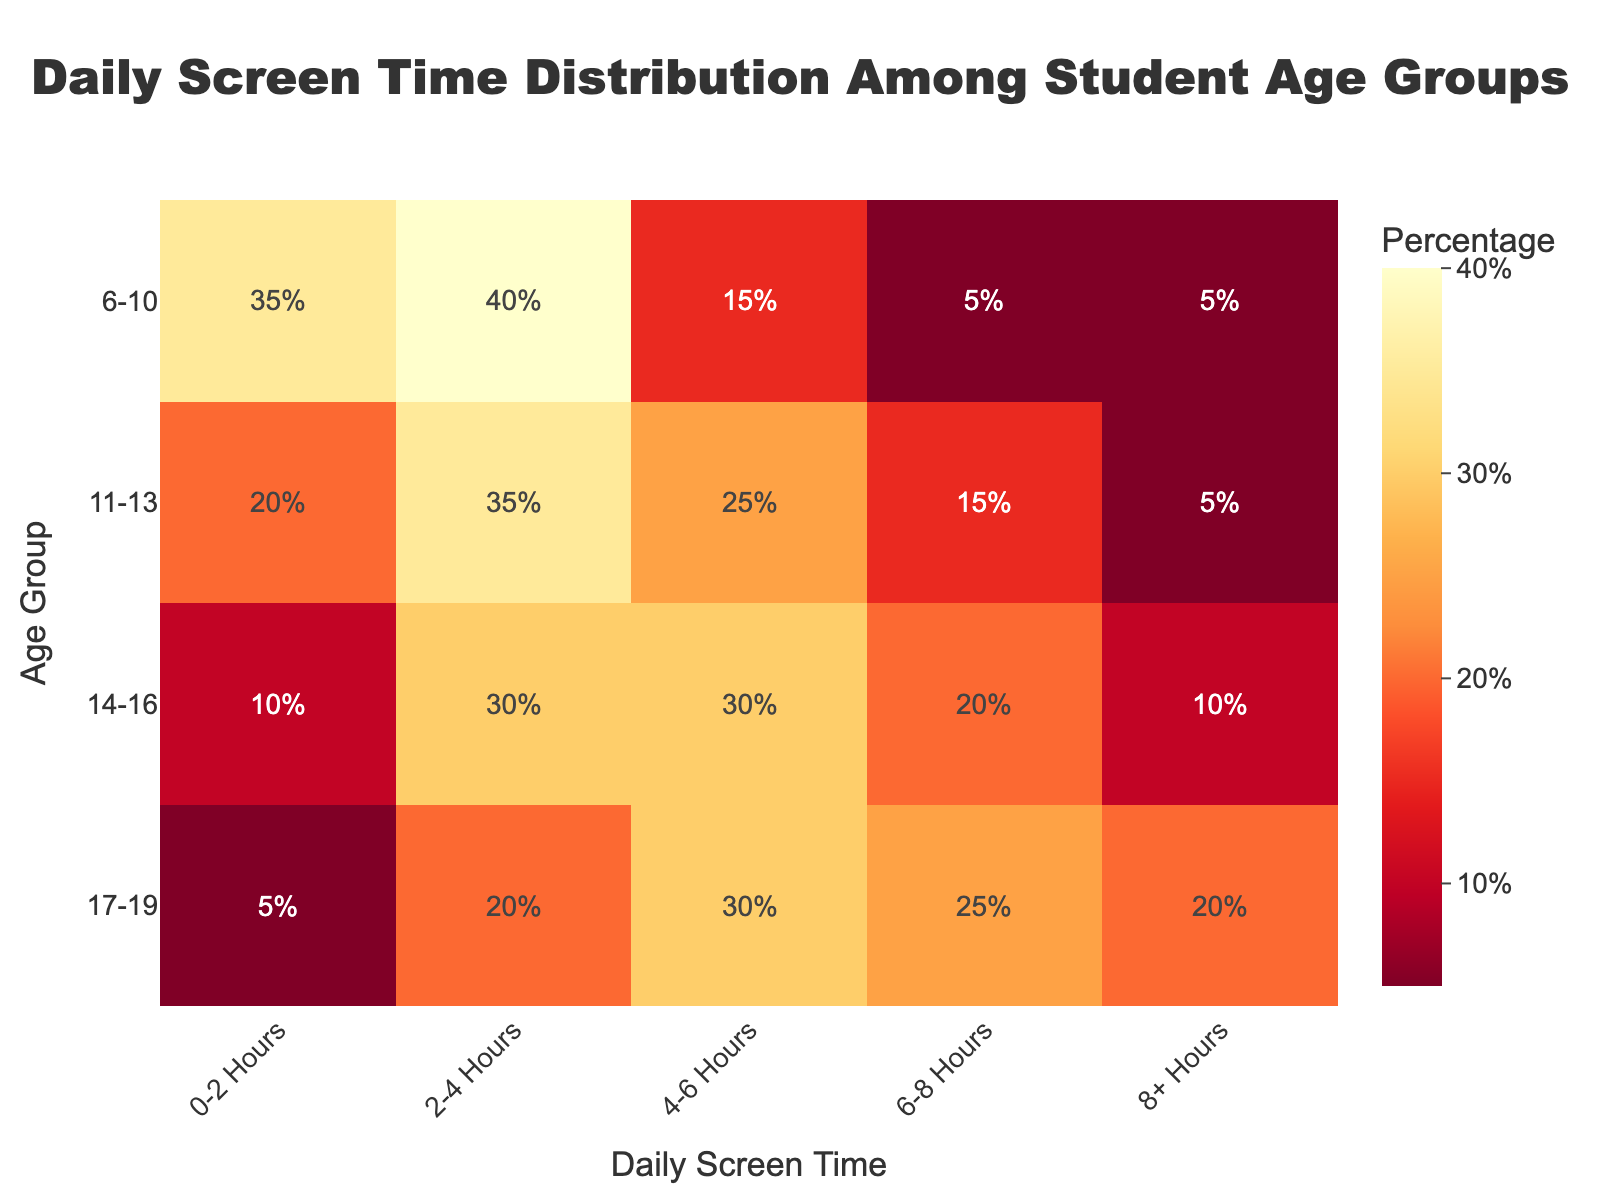What's the title of the heatmap? The title is located at the top center of the heatmap.
Answer: Daily Screen Time Distribution Among Student Age Groups Which age group has the highest percentage of students with 0-2 hours of screen time? Look at the column labeled '0-2 Hours' and find the highest value.
Answer: 6-10 In which screen time category do 14-16 year olds have the highest percentage? Find the row corresponding to 14-16 year olds and identify the column with the highest value.
Answer: 4-6 Hours How many percentage points more students aged 17-19 spend 8+ hours on screen compared to those aged 6-10? Subtract the percentage of 6-10 year olds in the '8+ Hours' column (5%) from the percentage of 17-19 year olds in the same column (20%).
Answer: 15% Which two age groups have the same percentage of students spending 8+ hours on screen? Find the '8+ Hours' column and look for rows with the same percentage.
Answer: 6-10 and 11-13 What is the difference in the percentage of students aged 14-16 who spend 4-6 hours on screen compared to those aged 11-13? Subtract the percentage in the 11-13 row from the percentage in the 14-16 row for the '4-6 Hours' column.
Answer: 5% Which screen time category has the least percentage of students aged 11-13? Look at the row for 11-13 year olds and identify the column with the lowest percentage.
Answer: 0-2 Hours What percentage of students aged 14-16 spend either 6-8 or 8+ hours on screen? Add the percentages for 6-8 hours (20%) and 8+ hours (10%) in the row for 14-16 year olds.
Answer: 30% Compare the percentage of students aged 6-10 and 17-19 who spend 2-4 hours on screen. Which age group has a higher percentage? Compare the values in the '2-4 Hours' column for the 6-10 and 17-19 age groups.
Answer: 6-10 What's the average percentage of students aged 11-13 across all screen time categories? Add the percentages for 11-13 year olds across all screen time categories (20% + 35% + 25% + 15% + 5%) and divide by the number of categories (5).
Answer: 20% 